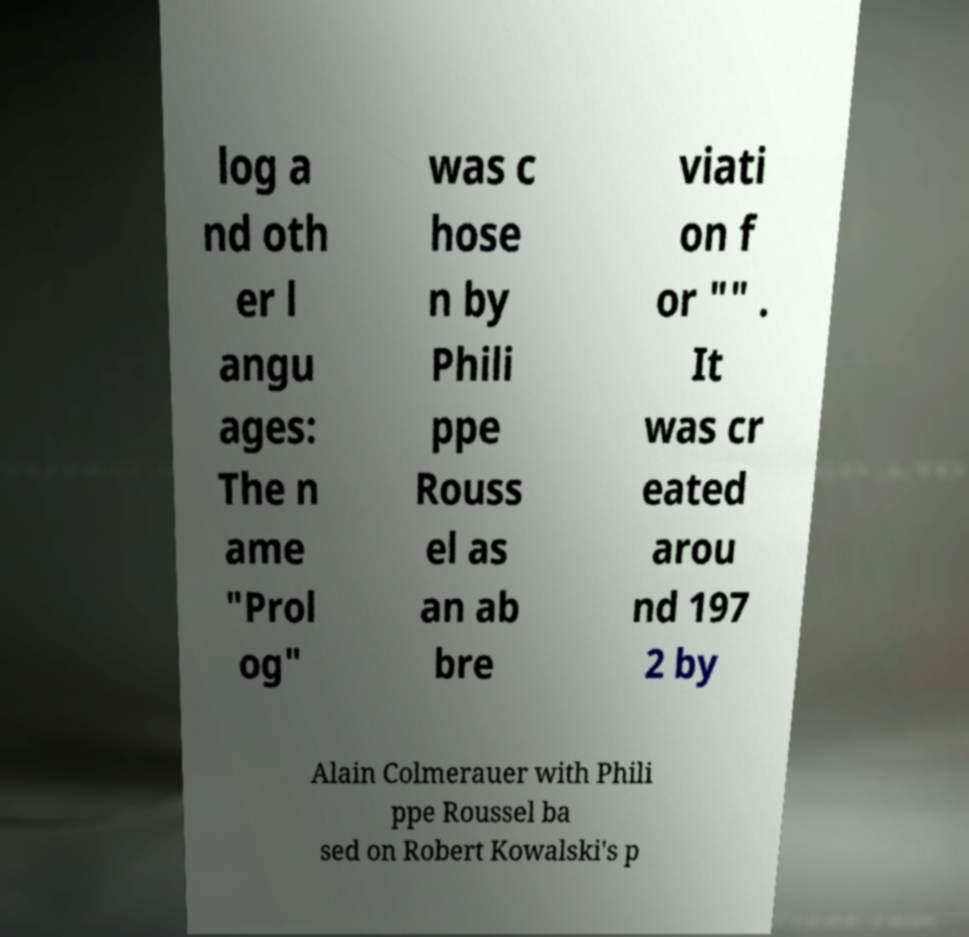I need the written content from this picture converted into text. Can you do that? log a nd oth er l angu ages: The n ame "Prol og" was c hose n by Phili ppe Rouss el as an ab bre viati on f or "" . It was cr eated arou nd 197 2 by Alain Colmerauer with Phili ppe Roussel ba sed on Robert Kowalski's p 